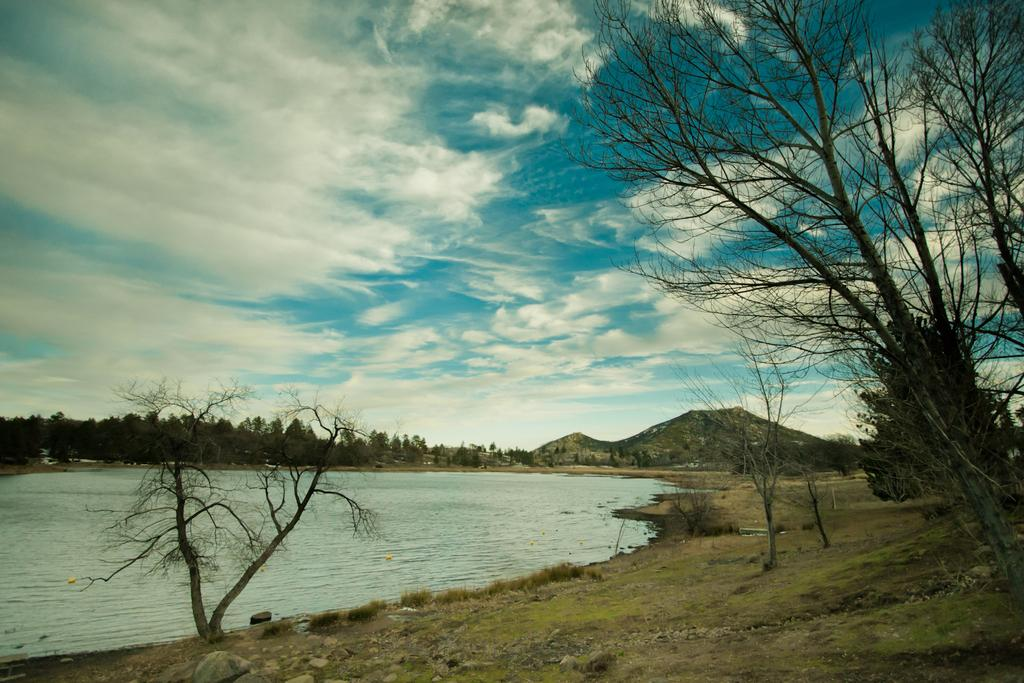What is the main feature of the image? There is an open ground in the image. What can be found on the open ground? There are multiple trees on the open ground. What is located in the center of the image? There is water in the center of the image. What can be seen in the background of the image? Mountains, clouds, and the sky are visible in the background. What type of watch is the crook wearing in the image? There is no crook or watch present in the image. Is there any sleet visible in the image? There is no sleet present in the image; the sky and water are visible. 